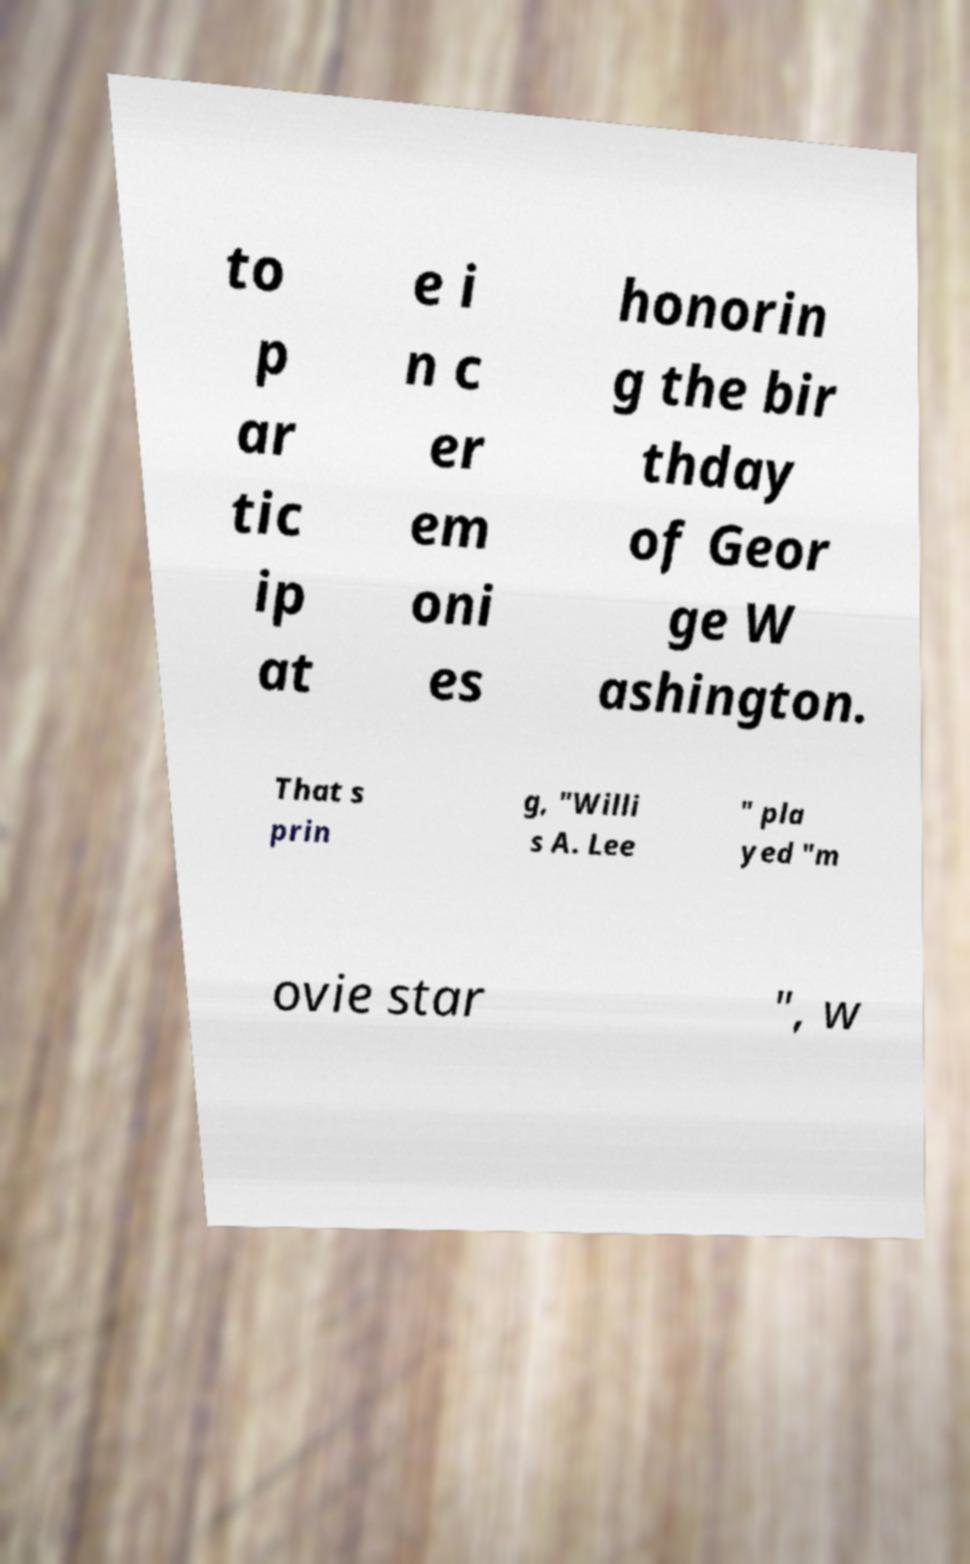There's text embedded in this image that I need extracted. Can you transcribe it verbatim? to p ar tic ip at e i n c er em oni es honorin g the bir thday of Geor ge W ashington. That s prin g, "Willi s A. Lee " pla yed "m ovie star ", w 